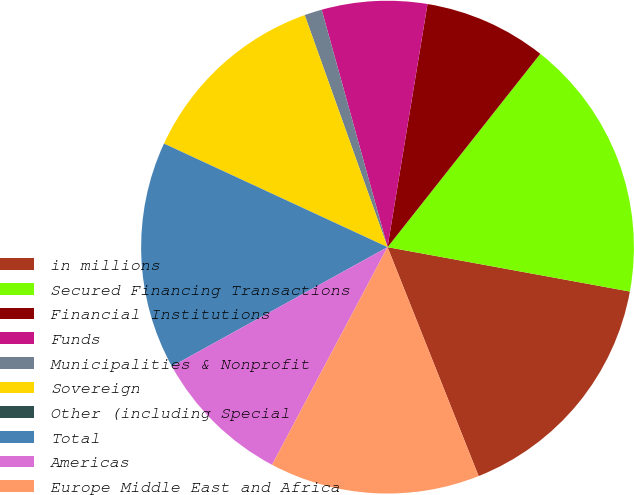Convert chart. <chart><loc_0><loc_0><loc_500><loc_500><pie_chart><fcel>in millions<fcel>Secured Financing Transactions<fcel>Financial Institutions<fcel>Funds<fcel>Municipalities & Nonprofit<fcel>Sovereign<fcel>Other (including Special<fcel>Total<fcel>Americas<fcel>Europe Middle East and Africa<nl><fcel>16.09%<fcel>17.24%<fcel>8.05%<fcel>6.9%<fcel>1.15%<fcel>12.64%<fcel>0.0%<fcel>14.94%<fcel>9.2%<fcel>13.79%<nl></chart> 